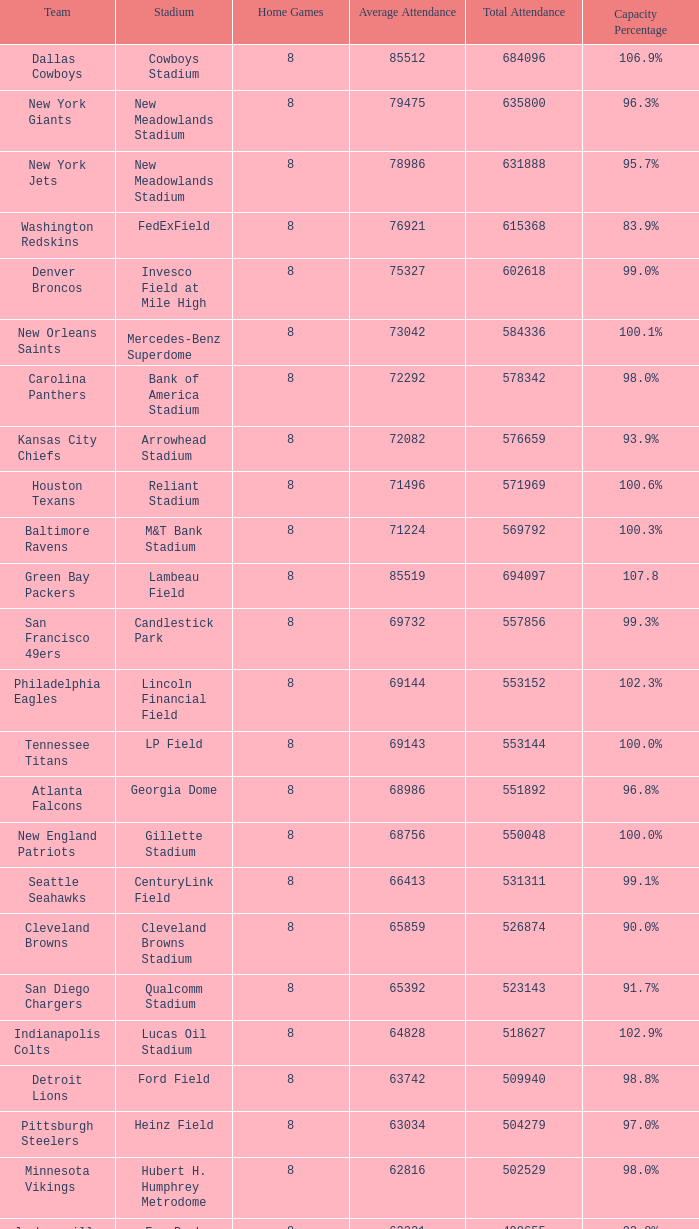What is the stadium's name when the occupancy rate is 8 FedExField. 